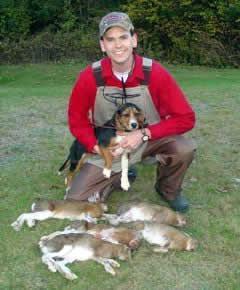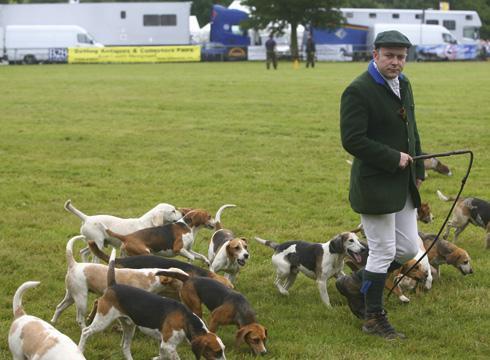The first image is the image on the left, the second image is the image on the right. Examine the images to the left and right. Is the description "A single man poses with at least one dog in the image on the left." accurate? Answer yes or no. Yes. 